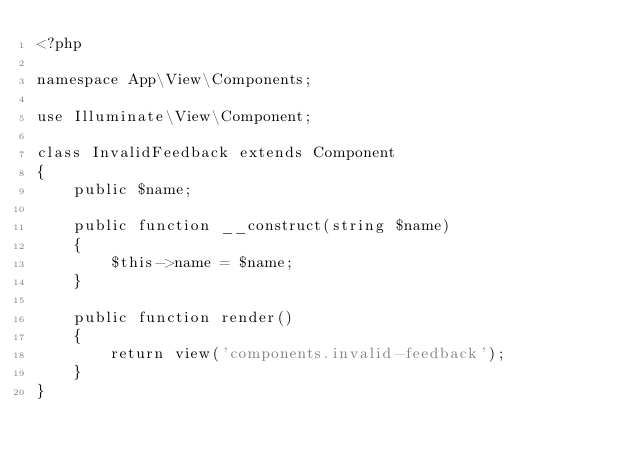Convert code to text. <code><loc_0><loc_0><loc_500><loc_500><_PHP_><?php

namespace App\View\Components;

use Illuminate\View\Component;

class InvalidFeedback extends Component
{
    public $name;

    public function __construct(string $name)
    {
        $this->name = $name;
    }

    public function render()
    {
        return view('components.invalid-feedback');
    }
}
</code> 